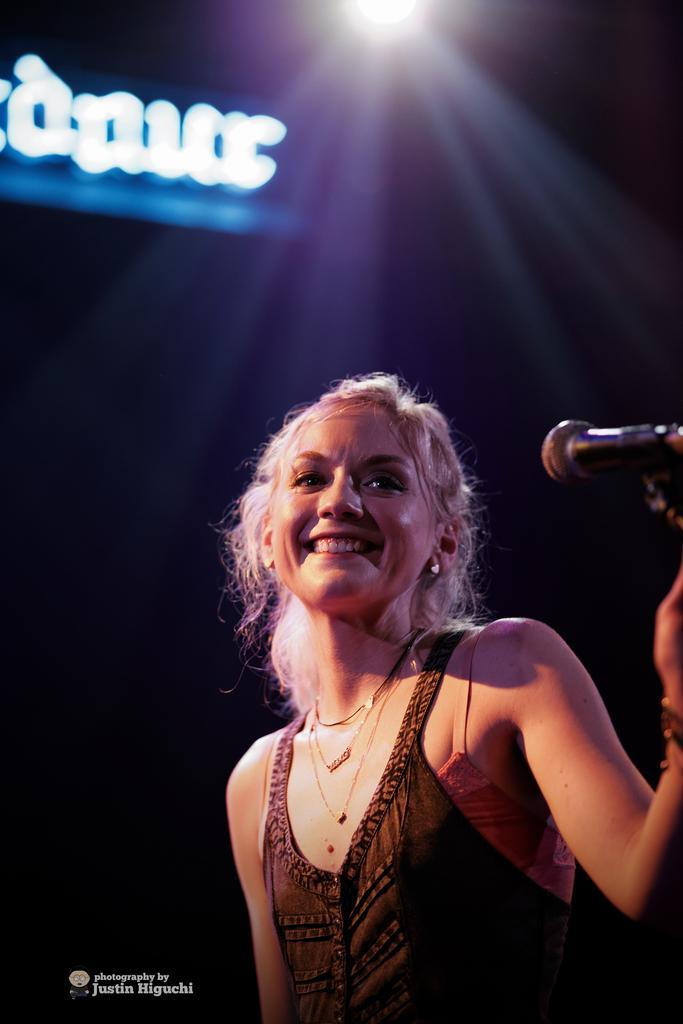How would you summarize this image in a sentence or two? In this image I can see a woman wearing brown colored dress and a microphone. I can see a light and the black colored background. 